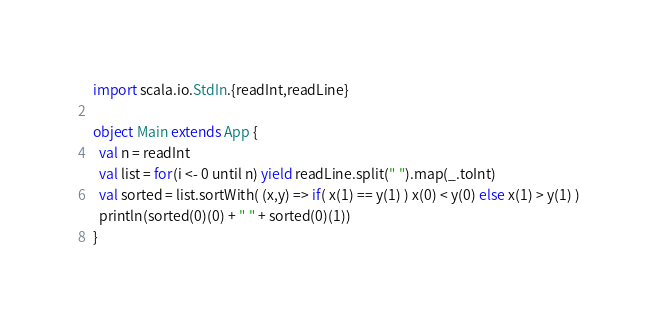Convert code to text. <code><loc_0><loc_0><loc_500><loc_500><_Scala_>import scala.io.StdIn.{readInt,readLine}

object Main extends App {
  val n = readInt
  val list = for(i <- 0 until n) yield readLine.split(" ").map(_.toInt)
  val sorted = list.sortWith( (x,y) => if( x(1) == y(1) ) x(0) < y(0) else x(1) > y(1) )
  println(sorted(0)(0) + " " + sorted(0)(1))
}</code> 